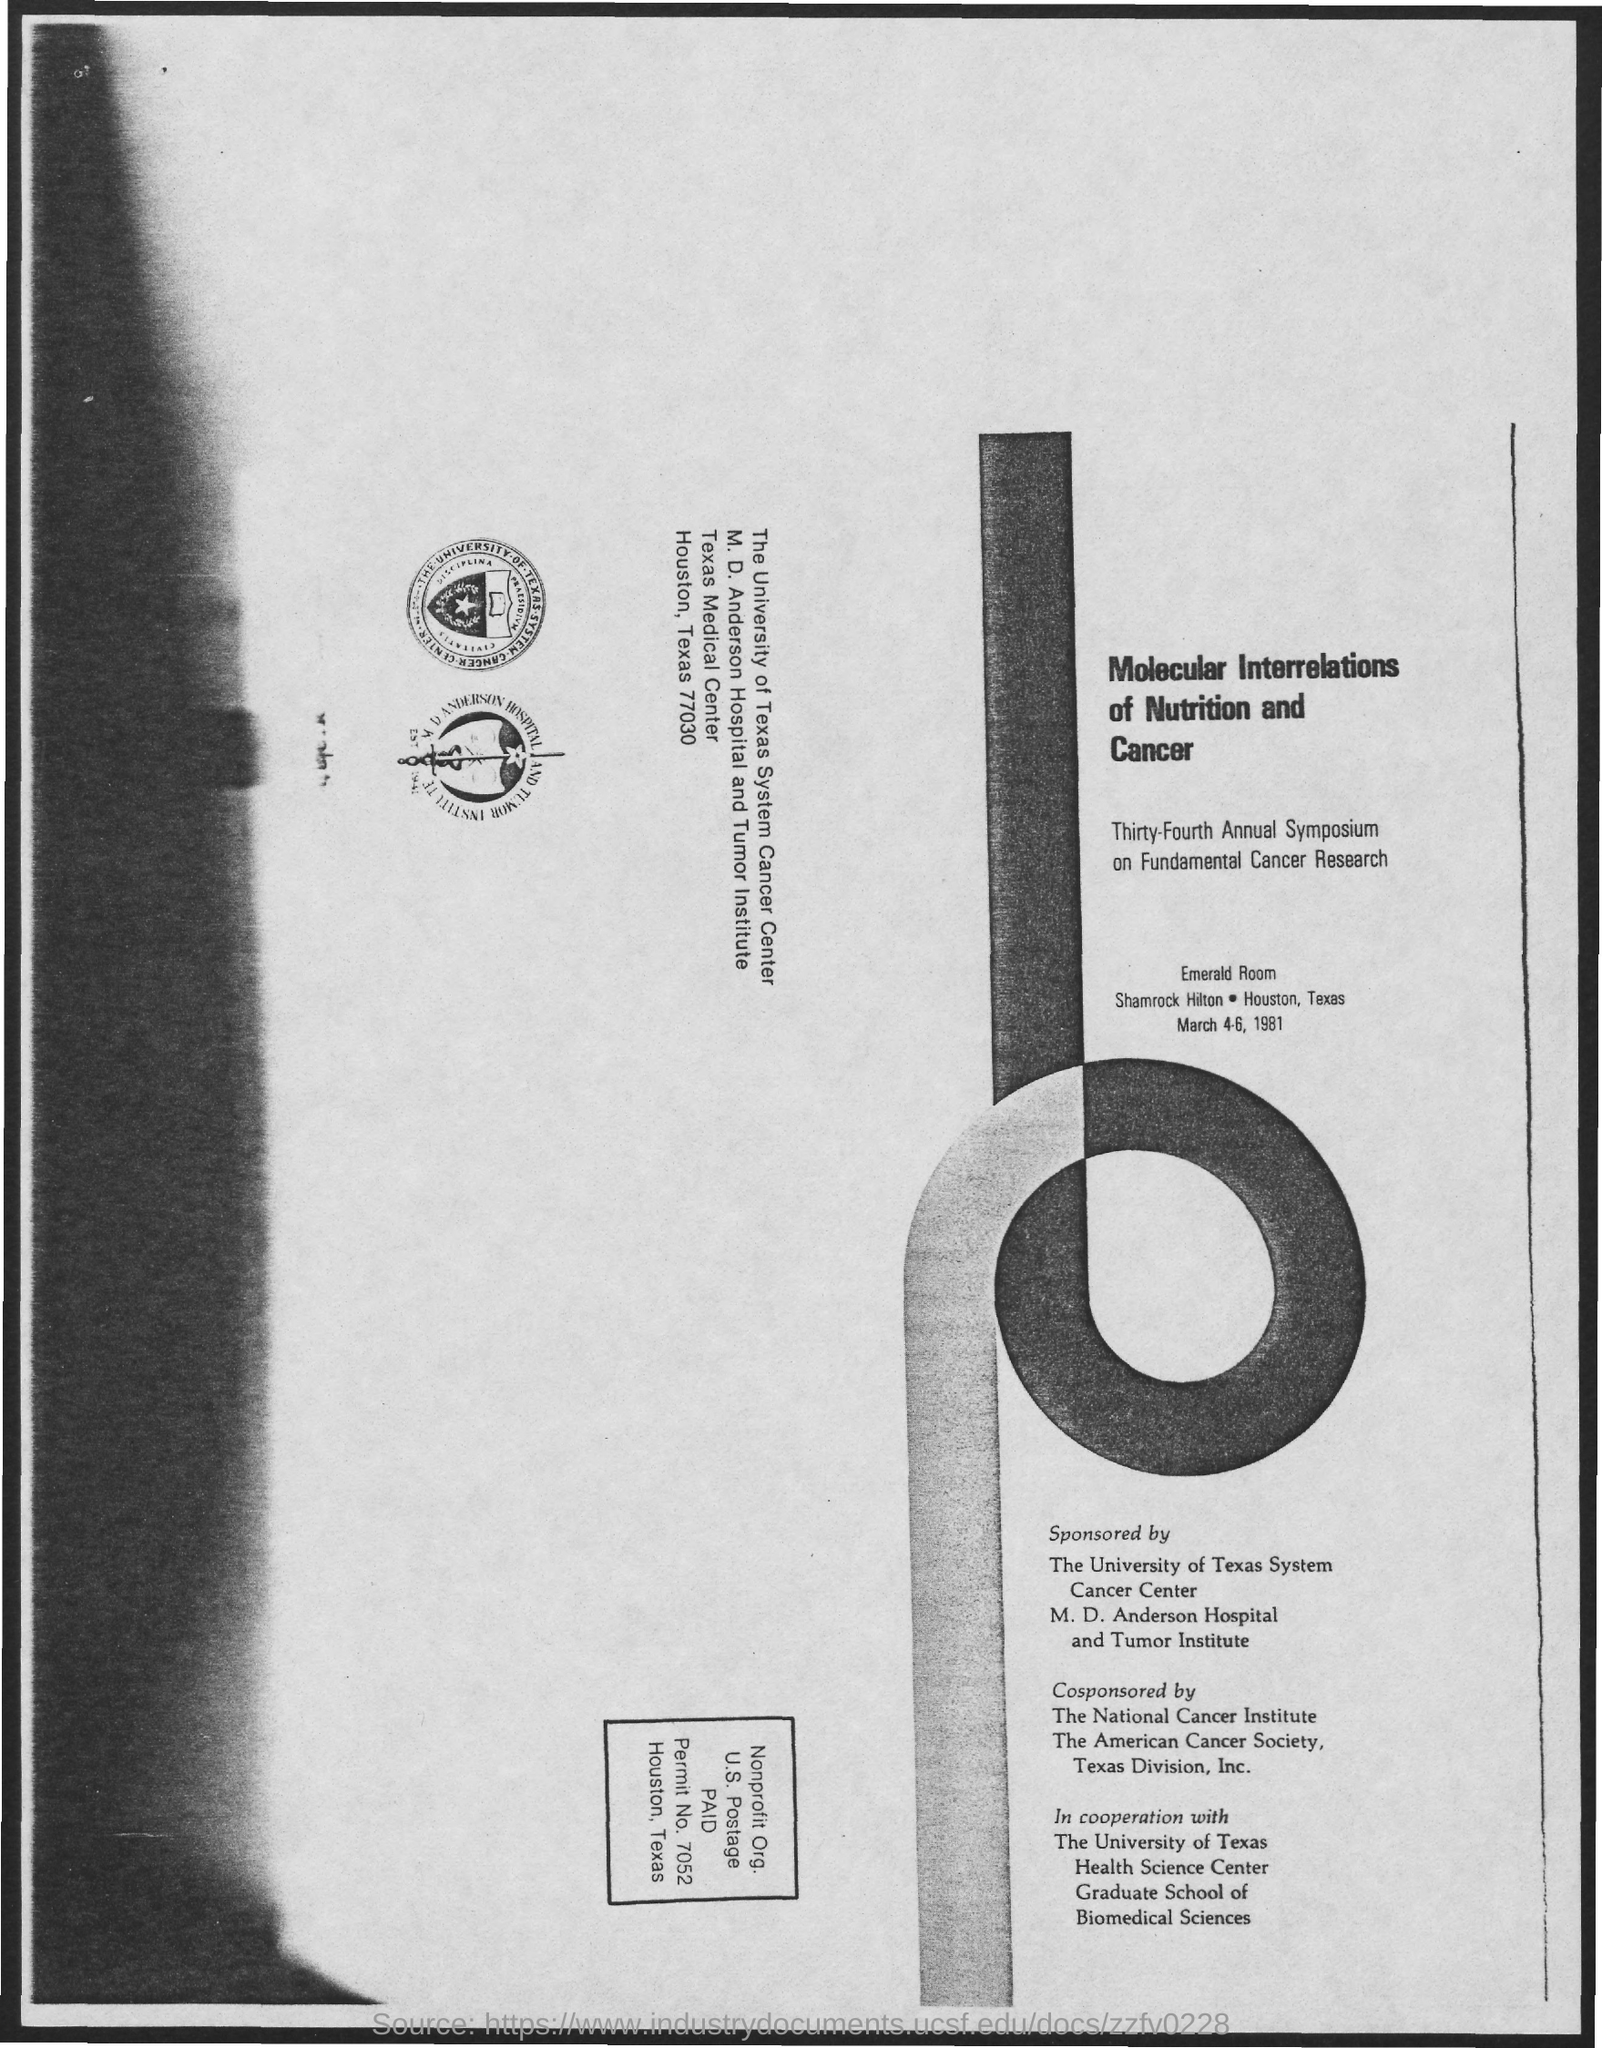Point out several critical features in this image. The Emerald Room is the name of the room mentioned in the given page. The molecular interrelations mentioned in the given page are those of nutrition and cancer. 